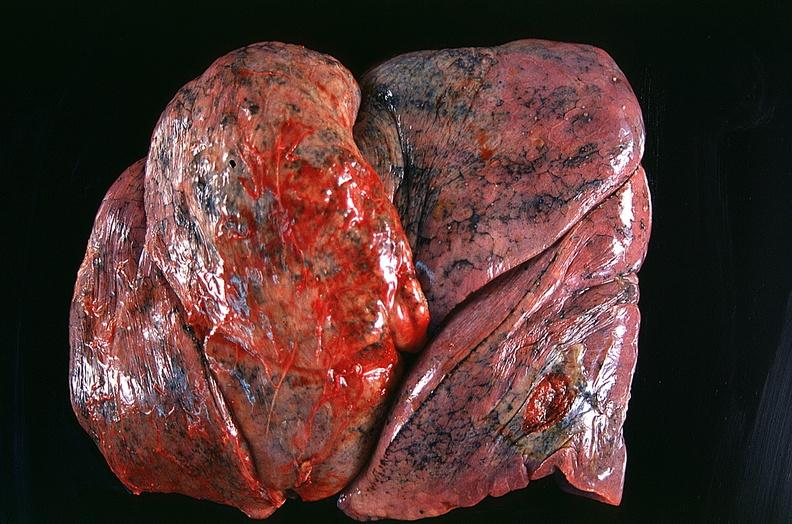does this image show lung, squamous cell carcinoma?
Answer the question using a single word or phrase. Yes 